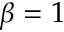<formula> <loc_0><loc_0><loc_500><loc_500>\beta = 1</formula> 